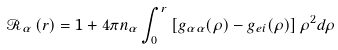Convert formula to latex. <formula><loc_0><loc_0><loc_500><loc_500>\mathcal { R } _ { \alpha } \left ( r \right ) = 1 + 4 \pi n _ { \alpha } \int _ { 0 } ^ { r } \left [ g _ { \alpha \alpha } ( \rho ) - g _ { e i } ( \rho ) \right ] \rho ^ { 2 } d \rho</formula> 